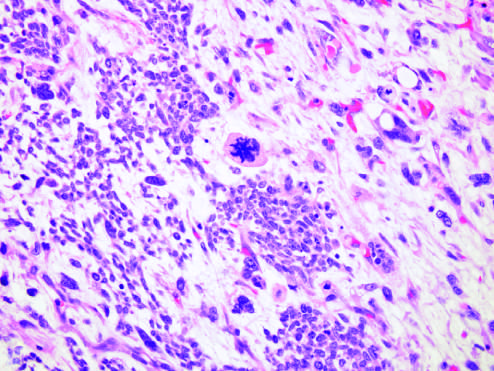re fish using a fluorescein-labeled cosmid probe for n-myc on a tissue section containing neuroblastoma associated with specific molecular lesions?
Answer the question using a single word or phrase. No 